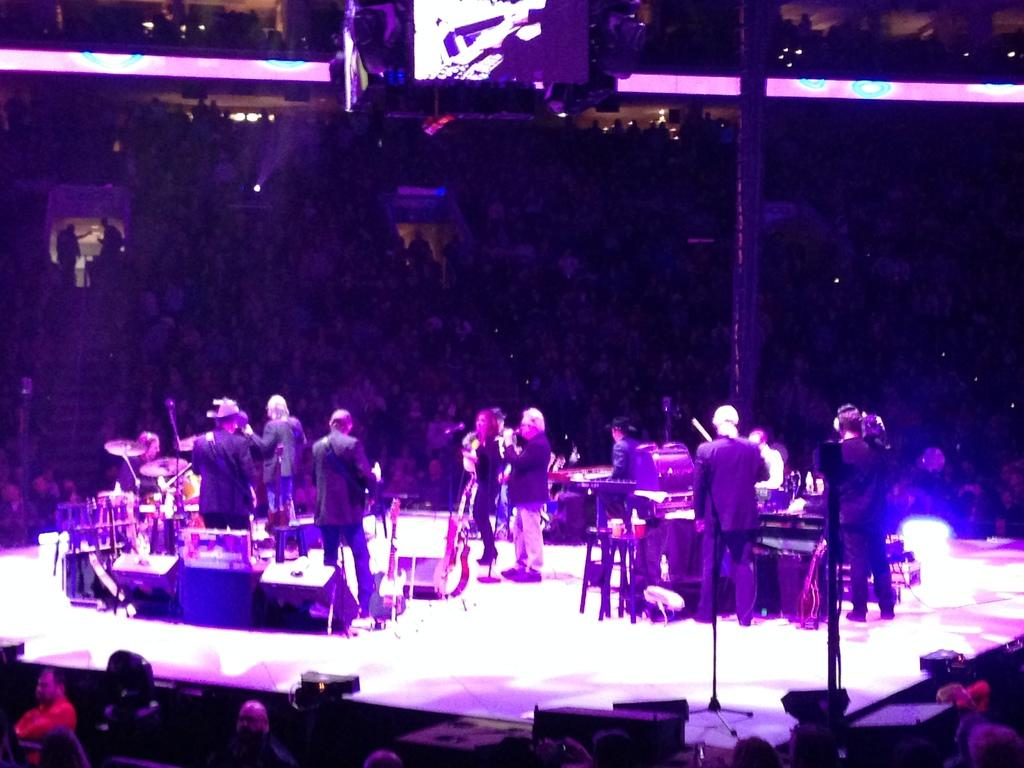What are the people in the image doing? People are playing musical instruments in the image. Can you describe the atmosphere in the image? There is a crowd in the image, which suggests a gathering or event. What can be seen illuminated in the image? There are lights visible in the image, which may be providing illumination for the event. What is the purpose of the pole in the image? The pole in the image may be used for supporting speakers or other equipment. What is used to amplify the sound in the image? Speakers are present in the image to amplify the sound. What is being displayed or projected in the image? There is a screen in the image, which may be used for displaying visuals or information. What type of art can be seen hanging from the pole in the image? There is no art hanging from the pole in the image; it is likely used for supporting speakers or other equipment. What sound do the bells make in the image? There are no bells present in the image, so it is not possible to determine the sound they would make. 